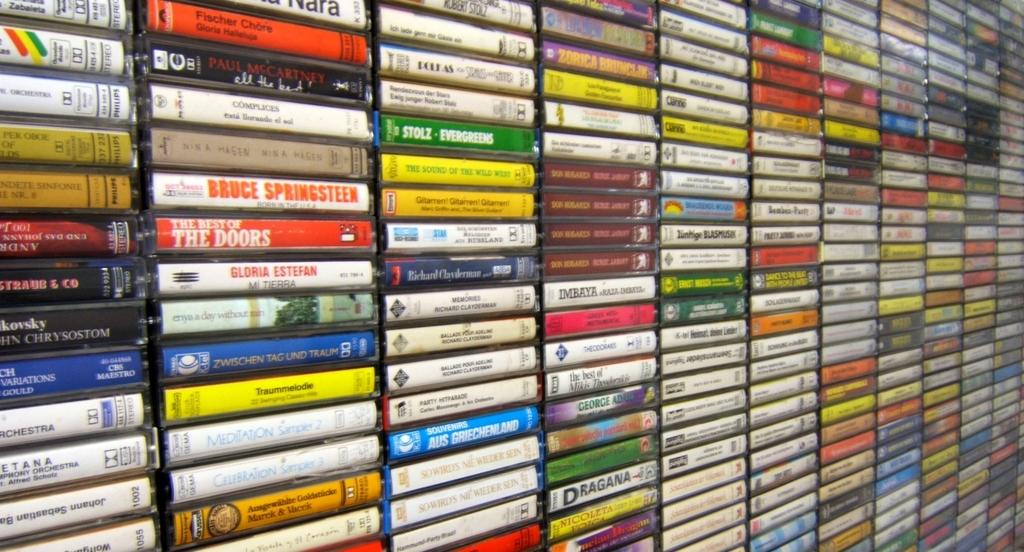<image>
Summarize the visual content of the image. A collection of music including The Doors and Bruce Springsteen. 